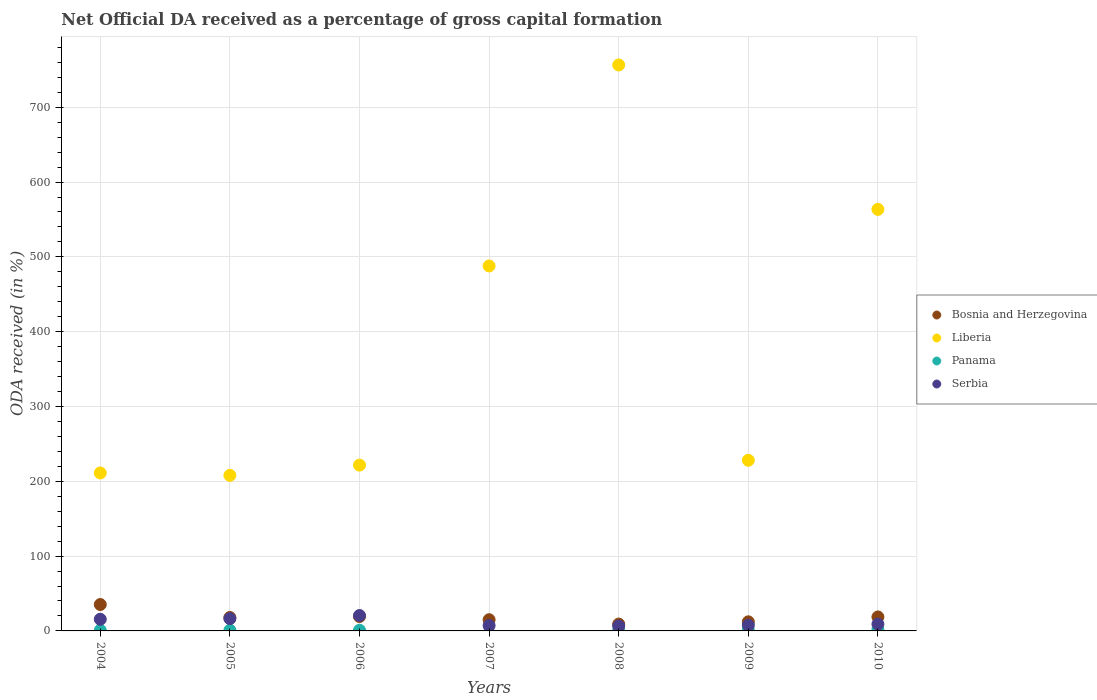What is the net ODA received in Panama in 2004?
Provide a succinct answer. 0.85. Across all years, what is the maximum net ODA received in Serbia?
Make the answer very short. 20.6. Across all years, what is the minimum net ODA received in Liberia?
Offer a very short reply. 207.93. What is the total net ODA received in Bosnia and Herzegovina in the graph?
Your answer should be compact. 127.48. What is the difference between the net ODA received in Serbia in 2005 and that in 2010?
Your answer should be compact. 7.35. What is the difference between the net ODA received in Liberia in 2004 and the net ODA received in Panama in 2010?
Ensure brevity in your answer.  209.27. What is the average net ODA received in Panama per year?
Give a very brief answer. 0.87. In the year 2009, what is the difference between the net ODA received in Serbia and net ODA received in Bosnia and Herzegovina?
Give a very brief answer. -4.62. What is the ratio of the net ODA received in Liberia in 2006 to that in 2007?
Provide a short and direct response. 0.45. What is the difference between the highest and the second highest net ODA received in Serbia?
Offer a very short reply. 4.19. What is the difference between the highest and the lowest net ODA received in Bosnia and Herzegovina?
Provide a succinct answer. 26.12. In how many years, is the net ODA received in Bosnia and Herzegovina greater than the average net ODA received in Bosnia and Herzegovina taken over all years?
Offer a very short reply. 3. Is the sum of the net ODA received in Panama in 2004 and 2008 greater than the maximum net ODA received in Bosnia and Herzegovina across all years?
Provide a succinct answer. No. Is it the case that in every year, the sum of the net ODA received in Bosnia and Herzegovina and net ODA received in Serbia  is greater than the sum of net ODA received in Panama and net ODA received in Liberia?
Ensure brevity in your answer.  No. Is it the case that in every year, the sum of the net ODA received in Serbia and net ODA received in Liberia  is greater than the net ODA received in Bosnia and Herzegovina?
Provide a succinct answer. Yes. Is the net ODA received in Panama strictly greater than the net ODA received in Serbia over the years?
Ensure brevity in your answer.  No. How many dotlines are there?
Give a very brief answer. 4. How many years are there in the graph?
Keep it short and to the point. 7. Does the graph contain grids?
Keep it short and to the point. Yes. Where does the legend appear in the graph?
Give a very brief answer. Center right. How many legend labels are there?
Your response must be concise. 4. How are the legend labels stacked?
Your answer should be very brief. Vertical. What is the title of the graph?
Ensure brevity in your answer.  Net Official DA received as a percentage of gross capital formation. Does "Macao" appear as one of the legend labels in the graph?
Ensure brevity in your answer.  No. What is the label or title of the X-axis?
Your answer should be compact. Years. What is the label or title of the Y-axis?
Provide a succinct answer. ODA received (in %). What is the ODA received (in %) of Bosnia and Herzegovina in 2004?
Keep it short and to the point. 35.29. What is the ODA received (in %) of Liberia in 2004?
Provide a succinct answer. 211.14. What is the ODA received (in %) in Panama in 2004?
Provide a short and direct response. 0.85. What is the ODA received (in %) in Serbia in 2004?
Make the answer very short. 15.6. What is the ODA received (in %) of Bosnia and Herzegovina in 2005?
Your answer should be very brief. 17.96. What is the ODA received (in %) of Liberia in 2005?
Offer a very short reply. 207.93. What is the ODA received (in %) of Panama in 2005?
Offer a terse response. 0.94. What is the ODA received (in %) in Serbia in 2005?
Your response must be concise. 16.41. What is the ODA received (in %) in Bosnia and Herzegovina in 2006?
Give a very brief answer. 19.22. What is the ODA received (in %) in Liberia in 2006?
Your answer should be compact. 221.64. What is the ODA received (in %) of Panama in 2006?
Your response must be concise. 0.93. What is the ODA received (in %) in Serbia in 2006?
Make the answer very short. 20.6. What is the ODA received (in %) in Bosnia and Herzegovina in 2007?
Give a very brief answer. 14.98. What is the ODA received (in %) in Liberia in 2007?
Give a very brief answer. 487.84. What is the ODA received (in %) of Panama in 2007?
Your answer should be very brief. 0. What is the ODA received (in %) in Serbia in 2007?
Offer a terse response. 7.16. What is the ODA received (in %) of Bosnia and Herzegovina in 2008?
Offer a very short reply. 9.17. What is the ODA received (in %) of Liberia in 2008?
Ensure brevity in your answer.  756.47. What is the ODA received (in %) in Panama in 2008?
Your response must be concise. 0.45. What is the ODA received (in %) in Serbia in 2008?
Your response must be concise. 6.51. What is the ODA received (in %) in Bosnia and Herzegovina in 2009?
Ensure brevity in your answer.  12.16. What is the ODA received (in %) in Liberia in 2009?
Provide a short and direct response. 228.08. What is the ODA received (in %) in Panama in 2009?
Offer a very short reply. 1.05. What is the ODA received (in %) in Serbia in 2009?
Your answer should be compact. 7.54. What is the ODA received (in %) of Bosnia and Herzegovina in 2010?
Keep it short and to the point. 18.69. What is the ODA received (in %) in Liberia in 2010?
Ensure brevity in your answer.  563.45. What is the ODA received (in %) in Panama in 2010?
Offer a terse response. 1.87. What is the ODA received (in %) in Serbia in 2010?
Ensure brevity in your answer.  9.05. Across all years, what is the maximum ODA received (in %) in Bosnia and Herzegovina?
Ensure brevity in your answer.  35.29. Across all years, what is the maximum ODA received (in %) of Liberia?
Provide a short and direct response. 756.47. Across all years, what is the maximum ODA received (in %) in Panama?
Make the answer very short. 1.87. Across all years, what is the maximum ODA received (in %) of Serbia?
Give a very brief answer. 20.6. Across all years, what is the minimum ODA received (in %) of Bosnia and Herzegovina?
Provide a short and direct response. 9.17. Across all years, what is the minimum ODA received (in %) of Liberia?
Make the answer very short. 207.93. Across all years, what is the minimum ODA received (in %) in Panama?
Provide a succinct answer. 0. Across all years, what is the minimum ODA received (in %) in Serbia?
Provide a succinct answer. 6.51. What is the total ODA received (in %) of Bosnia and Herzegovina in the graph?
Your response must be concise. 127.48. What is the total ODA received (in %) of Liberia in the graph?
Make the answer very short. 2676.56. What is the total ODA received (in %) of Panama in the graph?
Provide a short and direct response. 6.09. What is the total ODA received (in %) in Serbia in the graph?
Give a very brief answer. 82.88. What is the difference between the ODA received (in %) of Bosnia and Herzegovina in 2004 and that in 2005?
Your answer should be very brief. 17.33. What is the difference between the ODA received (in %) in Liberia in 2004 and that in 2005?
Your answer should be compact. 3.2. What is the difference between the ODA received (in %) in Panama in 2004 and that in 2005?
Keep it short and to the point. -0.09. What is the difference between the ODA received (in %) in Serbia in 2004 and that in 2005?
Your answer should be very brief. -0.81. What is the difference between the ODA received (in %) in Bosnia and Herzegovina in 2004 and that in 2006?
Provide a short and direct response. 16.07. What is the difference between the ODA received (in %) of Liberia in 2004 and that in 2006?
Ensure brevity in your answer.  -10.5. What is the difference between the ODA received (in %) of Panama in 2004 and that in 2006?
Your response must be concise. -0.08. What is the difference between the ODA received (in %) of Serbia in 2004 and that in 2006?
Provide a short and direct response. -5. What is the difference between the ODA received (in %) in Bosnia and Herzegovina in 2004 and that in 2007?
Your answer should be compact. 20.31. What is the difference between the ODA received (in %) of Liberia in 2004 and that in 2007?
Give a very brief answer. -276.7. What is the difference between the ODA received (in %) of Serbia in 2004 and that in 2007?
Make the answer very short. 8.44. What is the difference between the ODA received (in %) in Bosnia and Herzegovina in 2004 and that in 2008?
Your answer should be compact. 26.12. What is the difference between the ODA received (in %) in Liberia in 2004 and that in 2008?
Give a very brief answer. -545.33. What is the difference between the ODA received (in %) of Panama in 2004 and that in 2008?
Give a very brief answer. 0.4. What is the difference between the ODA received (in %) of Serbia in 2004 and that in 2008?
Provide a succinct answer. 9.09. What is the difference between the ODA received (in %) of Bosnia and Herzegovina in 2004 and that in 2009?
Your response must be concise. 23.13. What is the difference between the ODA received (in %) of Liberia in 2004 and that in 2009?
Your response must be concise. -16.95. What is the difference between the ODA received (in %) of Panama in 2004 and that in 2009?
Your answer should be very brief. -0.2. What is the difference between the ODA received (in %) of Serbia in 2004 and that in 2009?
Provide a short and direct response. 8.06. What is the difference between the ODA received (in %) in Bosnia and Herzegovina in 2004 and that in 2010?
Make the answer very short. 16.6. What is the difference between the ODA received (in %) in Liberia in 2004 and that in 2010?
Offer a terse response. -352.31. What is the difference between the ODA received (in %) in Panama in 2004 and that in 2010?
Offer a terse response. -1.01. What is the difference between the ODA received (in %) of Serbia in 2004 and that in 2010?
Offer a very short reply. 6.55. What is the difference between the ODA received (in %) of Bosnia and Herzegovina in 2005 and that in 2006?
Offer a very short reply. -1.26. What is the difference between the ODA received (in %) in Liberia in 2005 and that in 2006?
Ensure brevity in your answer.  -13.7. What is the difference between the ODA received (in %) of Panama in 2005 and that in 2006?
Ensure brevity in your answer.  0.01. What is the difference between the ODA received (in %) of Serbia in 2005 and that in 2006?
Your answer should be compact. -4.19. What is the difference between the ODA received (in %) in Bosnia and Herzegovina in 2005 and that in 2007?
Keep it short and to the point. 2.99. What is the difference between the ODA received (in %) in Liberia in 2005 and that in 2007?
Your response must be concise. -279.91. What is the difference between the ODA received (in %) in Serbia in 2005 and that in 2007?
Your answer should be compact. 9.24. What is the difference between the ODA received (in %) of Bosnia and Herzegovina in 2005 and that in 2008?
Your response must be concise. 8.79. What is the difference between the ODA received (in %) of Liberia in 2005 and that in 2008?
Make the answer very short. -548.54. What is the difference between the ODA received (in %) of Panama in 2005 and that in 2008?
Provide a succinct answer. 0.49. What is the difference between the ODA received (in %) of Serbia in 2005 and that in 2008?
Offer a very short reply. 9.89. What is the difference between the ODA received (in %) of Bosnia and Herzegovina in 2005 and that in 2009?
Your answer should be compact. 5.8. What is the difference between the ODA received (in %) in Liberia in 2005 and that in 2009?
Your answer should be very brief. -20.15. What is the difference between the ODA received (in %) of Panama in 2005 and that in 2009?
Offer a terse response. -0.11. What is the difference between the ODA received (in %) in Serbia in 2005 and that in 2009?
Your response must be concise. 8.87. What is the difference between the ODA received (in %) in Bosnia and Herzegovina in 2005 and that in 2010?
Provide a succinct answer. -0.73. What is the difference between the ODA received (in %) in Liberia in 2005 and that in 2010?
Your answer should be compact. -355.51. What is the difference between the ODA received (in %) in Panama in 2005 and that in 2010?
Give a very brief answer. -0.93. What is the difference between the ODA received (in %) in Serbia in 2005 and that in 2010?
Ensure brevity in your answer.  7.35. What is the difference between the ODA received (in %) in Bosnia and Herzegovina in 2006 and that in 2007?
Your answer should be compact. 4.24. What is the difference between the ODA received (in %) of Liberia in 2006 and that in 2007?
Give a very brief answer. -266.2. What is the difference between the ODA received (in %) in Serbia in 2006 and that in 2007?
Offer a terse response. 13.43. What is the difference between the ODA received (in %) in Bosnia and Herzegovina in 2006 and that in 2008?
Provide a succinct answer. 10.05. What is the difference between the ODA received (in %) of Liberia in 2006 and that in 2008?
Provide a succinct answer. -534.83. What is the difference between the ODA received (in %) in Panama in 2006 and that in 2008?
Your answer should be compact. 0.48. What is the difference between the ODA received (in %) of Serbia in 2006 and that in 2008?
Provide a succinct answer. 14.08. What is the difference between the ODA received (in %) of Bosnia and Herzegovina in 2006 and that in 2009?
Offer a terse response. 7.06. What is the difference between the ODA received (in %) in Liberia in 2006 and that in 2009?
Make the answer very short. -6.45. What is the difference between the ODA received (in %) in Panama in 2006 and that in 2009?
Your response must be concise. -0.12. What is the difference between the ODA received (in %) of Serbia in 2006 and that in 2009?
Provide a short and direct response. 13.06. What is the difference between the ODA received (in %) of Bosnia and Herzegovina in 2006 and that in 2010?
Offer a terse response. 0.53. What is the difference between the ODA received (in %) of Liberia in 2006 and that in 2010?
Provide a succinct answer. -341.81. What is the difference between the ODA received (in %) of Panama in 2006 and that in 2010?
Make the answer very short. -0.94. What is the difference between the ODA received (in %) in Serbia in 2006 and that in 2010?
Provide a short and direct response. 11.54. What is the difference between the ODA received (in %) of Bosnia and Herzegovina in 2007 and that in 2008?
Give a very brief answer. 5.81. What is the difference between the ODA received (in %) of Liberia in 2007 and that in 2008?
Your answer should be compact. -268.63. What is the difference between the ODA received (in %) of Serbia in 2007 and that in 2008?
Your answer should be very brief. 0.65. What is the difference between the ODA received (in %) in Bosnia and Herzegovina in 2007 and that in 2009?
Your response must be concise. 2.82. What is the difference between the ODA received (in %) in Liberia in 2007 and that in 2009?
Your answer should be compact. 259.76. What is the difference between the ODA received (in %) of Serbia in 2007 and that in 2009?
Provide a succinct answer. -0.37. What is the difference between the ODA received (in %) of Bosnia and Herzegovina in 2007 and that in 2010?
Give a very brief answer. -3.71. What is the difference between the ODA received (in %) of Liberia in 2007 and that in 2010?
Keep it short and to the point. -75.61. What is the difference between the ODA received (in %) of Serbia in 2007 and that in 2010?
Provide a short and direct response. -1.89. What is the difference between the ODA received (in %) in Bosnia and Herzegovina in 2008 and that in 2009?
Provide a succinct answer. -2.99. What is the difference between the ODA received (in %) in Liberia in 2008 and that in 2009?
Ensure brevity in your answer.  528.39. What is the difference between the ODA received (in %) of Panama in 2008 and that in 2009?
Your answer should be compact. -0.6. What is the difference between the ODA received (in %) of Serbia in 2008 and that in 2009?
Offer a terse response. -1.02. What is the difference between the ODA received (in %) in Bosnia and Herzegovina in 2008 and that in 2010?
Provide a short and direct response. -9.52. What is the difference between the ODA received (in %) of Liberia in 2008 and that in 2010?
Ensure brevity in your answer.  193.02. What is the difference between the ODA received (in %) of Panama in 2008 and that in 2010?
Offer a very short reply. -1.42. What is the difference between the ODA received (in %) in Serbia in 2008 and that in 2010?
Your answer should be very brief. -2.54. What is the difference between the ODA received (in %) in Bosnia and Herzegovina in 2009 and that in 2010?
Provide a short and direct response. -6.53. What is the difference between the ODA received (in %) in Liberia in 2009 and that in 2010?
Offer a terse response. -335.37. What is the difference between the ODA received (in %) of Panama in 2009 and that in 2010?
Your response must be concise. -0.81. What is the difference between the ODA received (in %) of Serbia in 2009 and that in 2010?
Your answer should be very brief. -1.52. What is the difference between the ODA received (in %) of Bosnia and Herzegovina in 2004 and the ODA received (in %) of Liberia in 2005?
Your response must be concise. -172.64. What is the difference between the ODA received (in %) of Bosnia and Herzegovina in 2004 and the ODA received (in %) of Panama in 2005?
Keep it short and to the point. 34.35. What is the difference between the ODA received (in %) of Bosnia and Herzegovina in 2004 and the ODA received (in %) of Serbia in 2005?
Ensure brevity in your answer.  18.88. What is the difference between the ODA received (in %) in Liberia in 2004 and the ODA received (in %) in Panama in 2005?
Offer a terse response. 210.2. What is the difference between the ODA received (in %) of Liberia in 2004 and the ODA received (in %) of Serbia in 2005?
Provide a short and direct response. 194.73. What is the difference between the ODA received (in %) of Panama in 2004 and the ODA received (in %) of Serbia in 2005?
Give a very brief answer. -15.56. What is the difference between the ODA received (in %) of Bosnia and Herzegovina in 2004 and the ODA received (in %) of Liberia in 2006?
Give a very brief answer. -186.35. What is the difference between the ODA received (in %) of Bosnia and Herzegovina in 2004 and the ODA received (in %) of Panama in 2006?
Give a very brief answer. 34.36. What is the difference between the ODA received (in %) in Bosnia and Herzegovina in 2004 and the ODA received (in %) in Serbia in 2006?
Your answer should be very brief. 14.69. What is the difference between the ODA received (in %) of Liberia in 2004 and the ODA received (in %) of Panama in 2006?
Your response must be concise. 210.21. What is the difference between the ODA received (in %) in Liberia in 2004 and the ODA received (in %) in Serbia in 2006?
Your response must be concise. 190.54. What is the difference between the ODA received (in %) in Panama in 2004 and the ODA received (in %) in Serbia in 2006?
Ensure brevity in your answer.  -19.75. What is the difference between the ODA received (in %) of Bosnia and Herzegovina in 2004 and the ODA received (in %) of Liberia in 2007?
Make the answer very short. -452.55. What is the difference between the ODA received (in %) of Bosnia and Herzegovina in 2004 and the ODA received (in %) of Serbia in 2007?
Make the answer very short. 28.13. What is the difference between the ODA received (in %) in Liberia in 2004 and the ODA received (in %) in Serbia in 2007?
Provide a succinct answer. 203.97. What is the difference between the ODA received (in %) of Panama in 2004 and the ODA received (in %) of Serbia in 2007?
Provide a succinct answer. -6.31. What is the difference between the ODA received (in %) of Bosnia and Herzegovina in 2004 and the ODA received (in %) of Liberia in 2008?
Your answer should be compact. -721.18. What is the difference between the ODA received (in %) in Bosnia and Herzegovina in 2004 and the ODA received (in %) in Panama in 2008?
Offer a very short reply. 34.84. What is the difference between the ODA received (in %) of Bosnia and Herzegovina in 2004 and the ODA received (in %) of Serbia in 2008?
Give a very brief answer. 28.78. What is the difference between the ODA received (in %) of Liberia in 2004 and the ODA received (in %) of Panama in 2008?
Offer a terse response. 210.69. What is the difference between the ODA received (in %) of Liberia in 2004 and the ODA received (in %) of Serbia in 2008?
Keep it short and to the point. 204.62. What is the difference between the ODA received (in %) of Panama in 2004 and the ODA received (in %) of Serbia in 2008?
Keep it short and to the point. -5.66. What is the difference between the ODA received (in %) in Bosnia and Herzegovina in 2004 and the ODA received (in %) in Liberia in 2009?
Provide a succinct answer. -192.79. What is the difference between the ODA received (in %) in Bosnia and Herzegovina in 2004 and the ODA received (in %) in Panama in 2009?
Your answer should be very brief. 34.24. What is the difference between the ODA received (in %) in Bosnia and Herzegovina in 2004 and the ODA received (in %) in Serbia in 2009?
Your answer should be compact. 27.75. What is the difference between the ODA received (in %) in Liberia in 2004 and the ODA received (in %) in Panama in 2009?
Keep it short and to the point. 210.09. What is the difference between the ODA received (in %) of Liberia in 2004 and the ODA received (in %) of Serbia in 2009?
Offer a terse response. 203.6. What is the difference between the ODA received (in %) of Panama in 2004 and the ODA received (in %) of Serbia in 2009?
Your answer should be compact. -6.69. What is the difference between the ODA received (in %) of Bosnia and Herzegovina in 2004 and the ODA received (in %) of Liberia in 2010?
Provide a short and direct response. -528.16. What is the difference between the ODA received (in %) in Bosnia and Herzegovina in 2004 and the ODA received (in %) in Panama in 2010?
Your response must be concise. 33.43. What is the difference between the ODA received (in %) of Bosnia and Herzegovina in 2004 and the ODA received (in %) of Serbia in 2010?
Provide a short and direct response. 26.24. What is the difference between the ODA received (in %) in Liberia in 2004 and the ODA received (in %) in Panama in 2010?
Your answer should be very brief. 209.27. What is the difference between the ODA received (in %) of Liberia in 2004 and the ODA received (in %) of Serbia in 2010?
Your answer should be very brief. 202.08. What is the difference between the ODA received (in %) of Panama in 2004 and the ODA received (in %) of Serbia in 2010?
Your answer should be compact. -8.2. What is the difference between the ODA received (in %) in Bosnia and Herzegovina in 2005 and the ODA received (in %) in Liberia in 2006?
Ensure brevity in your answer.  -203.68. What is the difference between the ODA received (in %) of Bosnia and Herzegovina in 2005 and the ODA received (in %) of Panama in 2006?
Keep it short and to the point. 17.03. What is the difference between the ODA received (in %) in Bosnia and Herzegovina in 2005 and the ODA received (in %) in Serbia in 2006?
Your answer should be very brief. -2.63. What is the difference between the ODA received (in %) of Liberia in 2005 and the ODA received (in %) of Panama in 2006?
Make the answer very short. 207. What is the difference between the ODA received (in %) in Liberia in 2005 and the ODA received (in %) in Serbia in 2006?
Offer a very short reply. 187.34. What is the difference between the ODA received (in %) in Panama in 2005 and the ODA received (in %) in Serbia in 2006?
Provide a short and direct response. -19.66. What is the difference between the ODA received (in %) of Bosnia and Herzegovina in 2005 and the ODA received (in %) of Liberia in 2007?
Make the answer very short. -469.88. What is the difference between the ODA received (in %) in Bosnia and Herzegovina in 2005 and the ODA received (in %) in Serbia in 2007?
Your response must be concise. 10.8. What is the difference between the ODA received (in %) of Liberia in 2005 and the ODA received (in %) of Serbia in 2007?
Offer a very short reply. 200.77. What is the difference between the ODA received (in %) in Panama in 2005 and the ODA received (in %) in Serbia in 2007?
Ensure brevity in your answer.  -6.22. What is the difference between the ODA received (in %) of Bosnia and Herzegovina in 2005 and the ODA received (in %) of Liberia in 2008?
Provide a succinct answer. -738.51. What is the difference between the ODA received (in %) in Bosnia and Herzegovina in 2005 and the ODA received (in %) in Panama in 2008?
Make the answer very short. 17.51. What is the difference between the ODA received (in %) of Bosnia and Herzegovina in 2005 and the ODA received (in %) of Serbia in 2008?
Offer a very short reply. 11.45. What is the difference between the ODA received (in %) of Liberia in 2005 and the ODA received (in %) of Panama in 2008?
Your response must be concise. 207.49. What is the difference between the ODA received (in %) of Liberia in 2005 and the ODA received (in %) of Serbia in 2008?
Make the answer very short. 201.42. What is the difference between the ODA received (in %) in Panama in 2005 and the ODA received (in %) in Serbia in 2008?
Offer a very short reply. -5.57. What is the difference between the ODA received (in %) of Bosnia and Herzegovina in 2005 and the ODA received (in %) of Liberia in 2009?
Offer a terse response. -210.12. What is the difference between the ODA received (in %) in Bosnia and Herzegovina in 2005 and the ODA received (in %) in Panama in 2009?
Make the answer very short. 16.91. What is the difference between the ODA received (in %) of Bosnia and Herzegovina in 2005 and the ODA received (in %) of Serbia in 2009?
Your answer should be compact. 10.43. What is the difference between the ODA received (in %) of Liberia in 2005 and the ODA received (in %) of Panama in 2009?
Provide a succinct answer. 206.88. What is the difference between the ODA received (in %) in Liberia in 2005 and the ODA received (in %) in Serbia in 2009?
Provide a succinct answer. 200.4. What is the difference between the ODA received (in %) in Panama in 2005 and the ODA received (in %) in Serbia in 2009?
Provide a succinct answer. -6.6. What is the difference between the ODA received (in %) in Bosnia and Herzegovina in 2005 and the ODA received (in %) in Liberia in 2010?
Provide a succinct answer. -545.49. What is the difference between the ODA received (in %) of Bosnia and Herzegovina in 2005 and the ODA received (in %) of Panama in 2010?
Give a very brief answer. 16.1. What is the difference between the ODA received (in %) of Bosnia and Herzegovina in 2005 and the ODA received (in %) of Serbia in 2010?
Provide a succinct answer. 8.91. What is the difference between the ODA received (in %) in Liberia in 2005 and the ODA received (in %) in Panama in 2010?
Make the answer very short. 206.07. What is the difference between the ODA received (in %) in Liberia in 2005 and the ODA received (in %) in Serbia in 2010?
Give a very brief answer. 198.88. What is the difference between the ODA received (in %) in Panama in 2005 and the ODA received (in %) in Serbia in 2010?
Offer a very short reply. -8.11. What is the difference between the ODA received (in %) in Bosnia and Herzegovina in 2006 and the ODA received (in %) in Liberia in 2007?
Your response must be concise. -468.62. What is the difference between the ODA received (in %) of Bosnia and Herzegovina in 2006 and the ODA received (in %) of Serbia in 2007?
Ensure brevity in your answer.  12.06. What is the difference between the ODA received (in %) in Liberia in 2006 and the ODA received (in %) in Serbia in 2007?
Provide a succinct answer. 214.47. What is the difference between the ODA received (in %) in Panama in 2006 and the ODA received (in %) in Serbia in 2007?
Offer a very short reply. -6.23. What is the difference between the ODA received (in %) in Bosnia and Herzegovina in 2006 and the ODA received (in %) in Liberia in 2008?
Give a very brief answer. -737.25. What is the difference between the ODA received (in %) of Bosnia and Herzegovina in 2006 and the ODA received (in %) of Panama in 2008?
Provide a succinct answer. 18.77. What is the difference between the ODA received (in %) in Bosnia and Herzegovina in 2006 and the ODA received (in %) in Serbia in 2008?
Your answer should be compact. 12.71. What is the difference between the ODA received (in %) in Liberia in 2006 and the ODA received (in %) in Panama in 2008?
Offer a terse response. 221.19. What is the difference between the ODA received (in %) of Liberia in 2006 and the ODA received (in %) of Serbia in 2008?
Your answer should be very brief. 215.12. What is the difference between the ODA received (in %) of Panama in 2006 and the ODA received (in %) of Serbia in 2008?
Your answer should be compact. -5.58. What is the difference between the ODA received (in %) in Bosnia and Herzegovina in 2006 and the ODA received (in %) in Liberia in 2009?
Ensure brevity in your answer.  -208.86. What is the difference between the ODA received (in %) in Bosnia and Herzegovina in 2006 and the ODA received (in %) in Panama in 2009?
Offer a very short reply. 18.17. What is the difference between the ODA received (in %) of Bosnia and Herzegovina in 2006 and the ODA received (in %) of Serbia in 2009?
Your response must be concise. 11.68. What is the difference between the ODA received (in %) in Liberia in 2006 and the ODA received (in %) in Panama in 2009?
Your response must be concise. 220.59. What is the difference between the ODA received (in %) in Liberia in 2006 and the ODA received (in %) in Serbia in 2009?
Provide a succinct answer. 214.1. What is the difference between the ODA received (in %) in Panama in 2006 and the ODA received (in %) in Serbia in 2009?
Make the answer very short. -6.61. What is the difference between the ODA received (in %) in Bosnia and Herzegovina in 2006 and the ODA received (in %) in Liberia in 2010?
Make the answer very short. -544.23. What is the difference between the ODA received (in %) in Bosnia and Herzegovina in 2006 and the ODA received (in %) in Panama in 2010?
Make the answer very short. 17.35. What is the difference between the ODA received (in %) of Bosnia and Herzegovina in 2006 and the ODA received (in %) of Serbia in 2010?
Offer a terse response. 10.17. What is the difference between the ODA received (in %) of Liberia in 2006 and the ODA received (in %) of Panama in 2010?
Provide a short and direct response. 219.77. What is the difference between the ODA received (in %) of Liberia in 2006 and the ODA received (in %) of Serbia in 2010?
Offer a terse response. 212.58. What is the difference between the ODA received (in %) of Panama in 2006 and the ODA received (in %) of Serbia in 2010?
Your answer should be compact. -8.12. What is the difference between the ODA received (in %) of Bosnia and Herzegovina in 2007 and the ODA received (in %) of Liberia in 2008?
Your answer should be compact. -741.49. What is the difference between the ODA received (in %) of Bosnia and Herzegovina in 2007 and the ODA received (in %) of Panama in 2008?
Your answer should be very brief. 14.53. What is the difference between the ODA received (in %) in Bosnia and Herzegovina in 2007 and the ODA received (in %) in Serbia in 2008?
Your answer should be compact. 8.46. What is the difference between the ODA received (in %) of Liberia in 2007 and the ODA received (in %) of Panama in 2008?
Your response must be concise. 487.39. What is the difference between the ODA received (in %) of Liberia in 2007 and the ODA received (in %) of Serbia in 2008?
Your answer should be very brief. 481.33. What is the difference between the ODA received (in %) of Bosnia and Herzegovina in 2007 and the ODA received (in %) of Liberia in 2009?
Your answer should be very brief. -213.11. What is the difference between the ODA received (in %) in Bosnia and Herzegovina in 2007 and the ODA received (in %) in Panama in 2009?
Offer a very short reply. 13.92. What is the difference between the ODA received (in %) of Bosnia and Herzegovina in 2007 and the ODA received (in %) of Serbia in 2009?
Provide a succinct answer. 7.44. What is the difference between the ODA received (in %) in Liberia in 2007 and the ODA received (in %) in Panama in 2009?
Your answer should be compact. 486.79. What is the difference between the ODA received (in %) in Liberia in 2007 and the ODA received (in %) in Serbia in 2009?
Provide a succinct answer. 480.3. What is the difference between the ODA received (in %) in Bosnia and Herzegovina in 2007 and the ODA received (in %) in Liberia in 2010?
Provide a succinct answer. -548.47. What is the difference between the ODA received (in %) in Bosnia and Herzegovina in 2007 and the ODA received (in %) in Panama in 2010?
Make the answer very short. 13.11. What is the difference between the ODA received (in %) of Bosnia and Herzegovina in 2007 and the ODA received (in %) of Serbia in 2010?
Your response must be concise. 5.92. What is the difference between the ODA received (in %) of Liberia in 2007 and the ODA received (in %) of Panama in 2010?
Your response must be concise. 485.97. What is the difference between the ODA received (in %) in Liberia in 2007 and the ODA received (in %) in Serbia in 2010?
Provide a short and direct response. 478.79. What is the difference between the ODA received (in %) in Bosnia and Herzegovina in 2008 and the ODA received (in %) in Liberia in 2009?
Make the answer very short. -218.91. What is the difference between the ODA received (in %) in Bosnia and Herzegovina in 2008 and the ODA received (in %) in Panama in 2009?
Offer a terse response. 8.12. What is the difference between the ODA received (in %) in Bosnia and Herzegovina in 2008 and the ODA received (in %) in Serbia in 2009?
Offer a terse response. 1.63. What is the difference between the ODA received (in %) of Liberia in 2008 and the ODA received (in %) of Panama in 2009?
Provide a succinct answer. 755.42. What is the difference between the ODA received (in %) of Liberia in 2008 and the ODA received (in %) of Serbia in 2009?
Make the answer very short. 748.93. What is the difference between the ODA received (in %) in Panama in 2008 and the ODA received (in %) in Serbia in 2009?
Give a very brief answer. -7.09. What is the difference between the ODA received (in %) in Bosnia and Herzegovina in 2008 and the ODA received (in %) in Liberia in 2010?
Offer a very short reply. -554.28. What is the difference between the ODA received (in %) of Bosnia and Herzegovina in 2008 and the ODA received (in %) of Panama in 2010?
Your answer should be compact. 7.31. What is the difference between the ODA received (in %) in Bosnia and Herzegovina in 2008 and the ODA received (in %) in Serbia in 2010?
Offer a terse response. 0.12. What is the difference between the ODA received (in %) in Liberia in 2008 and the ODA received (in %) in Panama in 2010?
Ensure brevity in your answer.  754.61. What is the difference between the ODA received (in %) of Liberia in 2008 and the ODA received (in %) of Serbia in 2010?
Your response must be concise. 747.42. What is the difference between the ODA received (in %) of Panama in 2008 and the ODA received (in %) of Serbia in 2010?
Give a very brief answer. -8.61. What is the difference between the ODA received (in %) in Bosnia and Herzegovina in 2009 and the ODA received (in %) in Liberia in 2010?
Provide a succinct answer. -551.29. What is the difference between the ODA received (in %) in Bosnia and Herzegovina in 2009 and the ODA received (in %) in Panama in 2010?
Make the answer very short. 10.3. What is the difference between the ODA received (in %) in Bosnia and Herzegovina in 2009 and the ODA received (in %) in Serbia in 2010?
Ensure brevity in your answer.  3.11. What is the difference between the ODA received (in %) of Liberia in 2009 and the ODA received (in %) of Panama in 2010?
Offer a very short reply. 226.22. What is the difference between the ODA received (in %) in Liberia in 2009 and the ODA received (in %) in Serbia in 2010?
Provide a short and direct response. 219.03. What is the difference between the ODA received (in %) of Panama in 2009 and the ODA received (in %) of Serbia in 2010?
Your response must be concise. -8. What is the average ODA received (in %) of Bosnia and Herzegovina per year?
Your answer should be compact. 18.21. What is the average ODA received (in %) in Liberia per year?
Provide a succinct answer. 382.37. What is the average ODA received (in %) in Panama per year?
Keep it short and to the point. 0.87. What is the average ODA received (in %) in Serbia per year?
Ensure brevity in your answer.  11.84. In the year 2004, what is the difference between the ODA received (in %) in Bosnia and Herzegovina and ODA received (in %) in Liberia?
Offer a very short reply. -175.85. In the year 2004, what is the difference between the ODA received (in %) in Bosnia and Herzegovina and ODA received (in %) in Panama?
Give a very brief answer. 34.44. In the year 2004, what is the difference between the ODA received (in %) in Bosnia and Herzegovina and ODA received (in %) in Serbia?
Offer a very short reply. 19.69. In the year 2004, what is the difference between the ODA received (in %) in Liberia and ODA received (in %) in Panama?
Your response must be concise. 210.29. In the year 2004, what is the difference between the ODA received (in %) of Liberia and ODA received (in %) of Serbia?
Offer a terse response. 195.54. In the year 2004, what is the difference between the ODA received (in %) of Panama and ODA received (in %) of Serbia?
Give a very brief answer. -14.75. In the year 2005, what is the difference between the ODA received (in %) of Bosnia and Herzegovina and ODA received (in %) of Liberia?
Ensure brevity in your answer.  -189.97. In the year 2005, what is the difference between the ODA received (in %) of Bosnia and Herzegovina and ODA received (in %) of Panama?
Offer a very short reply. 17.02. In the year 2005, what is the difference between the ODA received (in %) of Bosnia and Herzegovina and ODA received (in %) of Serbia?
Ensure brevity in your answer.  1.55. In the year 2005, what is the difference between the ODA received (in %) in Liberia and ODA received (in %) in Panama?
Your answer should be compact. 206.99. In the year 2005, what is the difference between the ODA received (in %) in Liberia and ODA received (in %) in Serbia?
Provide a short and direct response. 191.53. In the year 2005, what is the difference between the ODA received (in %) in Panama and ODA received (in %) in Serbia?
Offer a terse response. -15.47. In the year 2006, what is the difference between the ODA received (in %) of Bosnia and Herzegovina and ODA received (in %) of Liberia?
Ensure brevity in your answer.  -202.42. In the year 2006, what is the difference between the ODA received (in %) of Bosnia and Herzegovina and ODA received (in %) of Panama?
Your response must be concise. 18.29. In the year 2006, what is the difference between the ODA received (in %) in Bosnia and Herzegovina and ODA received (in %) in Serbia?
Give a very brief answer. -1.38. In the year 2006, what is the difference between the ODA received (in %) of Liberia and ODA received (in %) of Panama?
Offer a terse response. 220.71. In the year 2006, what is the difference between the ODA received (in %) of Liberia and ODA received (in %) of Serbia?
Provide a succinct answer. 201.04. In the year 2006, what is the difference between the ODA received (in %) in Panama and ODA received (in %) in Serbia?
Give a very brief answer. -19.67. In the year 2007, what is the difference between the ODA received (in %) of Bosnia and Herzegovina and ODA received (in %) of Liberia?
Offer a terse response. -472.86. In the year 2007, what is the difference between the ODA received (in %) of Bosnia and Herzegovina and ODA received (in %) of Serbia?
Offer a terse response. 7.81. In the year 2007, what is the difference between the ODA received (in %) of Liberia and ODA received (in %) of Serbia?
Your response must be concise. 480.68. In the year 2008, what is the difference between the ODA received (in %) of Bosnia and Herzegovina and ODA received (in %) of Liberia?
Your answer should be very brief. -747.3. In the year 2008, what is the difference between the ODA received (in %) in Bosnia and Herzegovina and ODA received (in %) in Panama?
Your answer should be very brief. 8.72. In the year 2008, what is the difference between the ODA received (in %) of Bosnia and Herzegovina and ODA received (in %) of Serbia?
Ensure brevity in your answer.  2.66. In the year 2008, what is the difference between the ODA received (in %) in Liberia and ODA received (in %) in Panama?
Your response must be concise. 756.02. In the year 2008, what is the difference between the ODA received (in %) in Liberia and ODA received (in %) in Serbia?
Provide a succinct answer. 749.96. In the year 2008, what is the difference between the ODA received (in %) in Panama and ODA received (in %) in Serbia?
Your answer should be compact. -6.07. In the year 2009, what is the difference between the ODA received (in %) of Bosnia and Herzegovina and ODA received (in %) of Liberia?
Provide a succinct answer. -215.92. In the year 2009, what is the difference between the ODA received (in %) in Bosnia and Herzegovina and ODA received (in %) in Panama?
Offer a terse response. 11.11. In the year 2009, what is the difference between the ODA received (in %) of Bosnia and Herzegovina and ODA received (in %) of Serbia?
Keep it short and to the point. 4.62. In the year 2009, what is the difference between the ODA received (in %) of Liberia and ODA received (in %) of Panama?
Keep it short and to the point. 227.03. In the year 2009, what is the difference between the ODA received (in %) in Liberia and ODA received (in %) in Serbia?
Offer a very short reply. 220.55. In the year 2009, what is the difference between the ODA received (in %) in Panama and ODA received (in %) in Serbia?
Offer a terse response. -6.48. In the year 2010, what is the difference between the ODA received (in %) of Bosnia and Herzegovina and ODA received (in %) of Liberia?
Offer a very short reply. -544.76. In the year 2010, what is the difference between the ODA received (in %) in Bosnia and Herzegovina and ODA received (in %) in Panama?
Your answer should be compact. 16.82. In the year 2010, what is the difference between the ODA received (in %) of Bosnia and Herzegovina and ODA received (in %) of Serbia?
Provide a succinct answer. 9.64. In the year 2010, what is the difference between the ODA received (in %) in Liberia and ODA received (in %) in Panama?
Provide a short and direct response. 561.58. In the year 2010, what is the difference between the ODA received (in %) in Liberia and ODA received (in %) in Serbia?
Provide a succinct answer. 554.4. In the year 2010, what is the difference between the ODA received (in %) of Panama and ODA received (in %) of Serbia?
Keep it short and to the point. -7.19. What is the ratio of the ODA received (in %) of Bosnia and Herzegovina in 2004 to that in 2005?
Provide a short and direct response. 1.96. What is the ratio of the ODA received (in %) of Liberia in 2004 to that in 2005?
Give a very brief answer. 1.02. What is the ratio of the ODA received (in %) of Panama in 2004 to that in 2005?
Keep it short and to the point. 0.91. What is the ratio of the ODA received (in %) in Serbia in 2004 to that in 2005?
Make the answer very short. 0.95. What is the ratio of the ODA received (in %) in Bosnia and Herzegovina in 2004 to that in 2006?
Your response must be concise. 1.84. What is the ratio of the ODA received (in %) in Liberia in 2004 to that in 2006?
Your answer should be very brief. 0.95. What is the ratio of the ODA received (in %) of Panama in 2004 to that in 2006?
Keep it short and to the point. 0.92. What is the ratio of the ODA received (in %) of Serbia in 2004 to that in 2006?
Provide a succinct answer. 0.76. What is the ratio of the ODA received (in %) in Bosnia and Herzegovina in 2004 to that in 2007?
Your answer should be compact. 2.36. What is the ratio of the ODA received (in %) in Liberia in 2004 to that in 2007?
Make the answer very short. 0.43. What is the ratio of the ODA received (in %) in Serbia in 2004 to that in 2007?
Offer a very short reply. 2.18. What is the ratio of the ODA received (in %) in Bosnia and Herzegovina in 2004 to that in 2008?
Offer a very short reply. 3.85. What is the ratio of the ODA received (in %) in Liberia in 2004 to that in 2008?
Your answer should be very brief. 0.28. What is the ratio of the ODA received (in %) of Panama in 2004 to that in 2008?
Your response must be concise. 1.9. What is the ratio of the ODA received (in %) in Serbia in 2004 to that in 2008?
Your answer should be compact. 2.39. What is the ratio of the ODA received (in %) of Bosnia and Herzegovina in 2004 to that in 2009?
Your answer should be compact. 2.9. What is the ratio of the ODA received (in %) of Liberia in 2004 to that in 2009?
Ensure brevity in your answer.  0.93. What is the ratio of the ODA received (in %) in Panama in 2004 to that in 2009?
Ensure brevity in your answer.  0.81. What is the ratio of the ODA received (in %) in Serbia in 2004 to that in 2009?
Offer a very short reply. 2.07. What is the ratio of the ODA received (in %) in Bosnia and Herzegovina in 2004 to that in 2010?
Your answer should be compact. 1.89. What is the ratio of the ODA received (in %) of Liberia in 2004 to that in 2010?
Offer a terse response. 0.37. What is the ratio of the ODA received (in %) of Panama in 2004 to that in 2010?
Provide a short and direct response. 0.46. What is the ratio of the ODA received (in %) in Serbia in 2004 to that in 2010?
Provide a succinct answer. 1.72. What is the ratio of the ODA received (in %) in Bosnia and Herzegovina in 2005 to that in 2006?
Your response must be concise. 0.93. What is the ratio of the ODA received (in %) in Liberia in 2005 to that in 2006?
Your answer should be compact. 0.94. What is the ratio of the ODA received (in %) in Serbia in 2005 to that in 2006?
Keep it short and to the point. 0.8. What is the ratio of the ODA received (in %) in Bosnia and Herzegovina in 2005 to that in 2007?
Your response must be concise. 1.2. What is the ratio of the ODA received (in %) in Liberia in 2005 to that in 2007?
Ensure brevity in your answer.  0.43. What is the ratio of the ODA received (in %) in Serbia in 2005 to that in 2007?
Your response must be concise. 2.29. What is the ratio of the ODA received (in %) in Bosnia and Herzegovina in 2005 to that in 2008?
Give a very brief answer. 1.96. What is the ratio of the ODA received (in %) of Liberia in 2005 to that in 2008?
Your answer should be compact. 0.27. What is the ratio of the ODA received (in %) of Panama in 2005 to that in 2008?
Ensure brevity in your answer.  2.09. What is the ratio of the ODA received (in %) in Serbia in 2005 to that in 2008?
Your answer should be very brief. 2.52. What is the ratio of the ODA received (in %) in Bosnia and Herzegovina in 2005 to that in 2009?
Your answer should be very brief. 1.48. What is the ratio of the ODA received (in %) of Liberia in 2005 to that in 2009?
Provide a short and direct response. 0.91. What is the ratio of the ODA received (in %) in Panama in 2005 to that in 2009?
Provide a short and direct response. 0.89. What is the ratio of the ODA received (in %) in Serbia in 2005 to that in 2009?
Keep it short and to the point. 2.18. What is the ratio of the ODA received (in %) in Bosnia and Herzegovina in 2005 to that in 2010?
Offer a terse response. 0.96. What is the ratio of the ODA received (in %) in Liberia in 2005 to that in 2010?
Your response must be concise. 0.37. What is the ratio of the ODA received (in %) in Panama in 2005 to that in 2010?
Give a very brief answer. 0.5. What is the ratio of the ODA received (in %) of Serbia in 2005 to that in 2010?
Your answer should be compact. 1.81. What is the ratio of the ODA received (in %) of Bosnia and Herzegovina in 2006 to that in 2007?
Offer a very short reply. 1.28. What is the ratio of the ODA received (in %) in Liberia in 2006 to that in 2007?
Offer a terse response. 0.45. What is the ratio of the ODA received (in %) in Serbia in 2006 to that in 2007?
Your response must be concise. 2.87. What is the ratio of the ODA received (in %) in Bosnia and Herzegovina in 2006 to that in 2008?
Give a very brief answer. 2.1. What is the ratio of the ODA received (in %) of Liberia in 2006 to that in 2008?
Your answer should be very brief. 0.29. What is the ratio of the ODA received (in %) of Panama in 2006 to that in 2008?
Provide a short and direct response. 2.07. What is the ratio of the ODA received (in %) of Serbia in 2006 to that in 2008?
Your answer should be compact. 3.16. What is the ratio of the ODA received (in %) in Bosnia and Herzegovina in 2006 to that in 2009?
Keep it short and to the point. 1.58. What is the ratio of the ODA received (in %) of Liberia in 2006 to that in 2009?
Your answer should be very brief. 0.97. What is the ratio of the ODA received (in %) of Panama in 2006 to that in 2009?
Provide a short and direct response. 0.88. What is the ratio of the ODA received (in %) of Serbia in 2006 to that in 2009?
Make the answer very short. 2.73. What is the ratio of the ODA received (in %) of Bosnia and Herzegovina in 2006 to that in 2010?
Your answer should be very brief. 1.03. What is the ratio of the ODA received (in %) of Liberia in 2006 to that in 2010?
Your answer should be compact. 0.39. What is the ratio of the ODA received (in %) of Panama in 2006 to that in 2010?
Keep it short and to the point. 0.5. What is the ratio of the ODA received (in %) in Serbia in 2006 to that in 2010?
Your answer should be compact. 2.27. What is the ratio of the ODA received (in %) of Bosnia and Herzegovina in 2007 to that in 2008?
Your answer should be very brief. 1.63. What is the ratio of the ODA received (in %) of Liberia in 2007 to that in 2008?
Your answer should be very brief. 0.64. What is the ratio of the ODA received (in %) of Serbia in 2007 to that in 2008?
Offer a very short reply. 1.1. What is the ratio of the ODA received (in %) of Bosnia and Herzegovina in 2007 to that in 2009?
Offer a very short reply. 1.23. What is the ratio of the ODA received (in %) of Liberia in 2007 to that in 2009?
Your answer should be very brief. 2.14. What is the ratio of the ODA received (in %) in Serbia in 2007 to that in 2009?
Your response must be concise. 0.95. What is the ratio of the ODA received (in %) of Bosnia and Herzegovina in 2007 to that in 2010?
Ensure brevity in your answer.  0.8. What is the ratio of the ODA received (in %) of Liberia in 2007 to that in 2010?
Your answer should be very brief. 0.87. What is the ratio of the ODA received (in %) of Serbia in 2007 to that in 2010?
Provide a short and direct response. 0.79. What is the ratio of the ODA received (in %) in Bosnia and Herzegovina in 2008 to that in 2009?
Your response must be concise. 0.75. What is the ratio of the ODA received (in %) of Liberia in 2008 to that in 2009?
Give a very brief answer. 3.32. What is the ratio of the ODA received (in %) of Panama in 2008 to that in 2009?
Offer a very short reply. 0.43. What is the ratio of the ODA received (in %) in Serbia in 2008 to that in 2009?
Ensure brevity in your answer.  0.86. What is the ratio of the ODA received (in %) of Bosnia and Herzegovina in 2008 to that in 2010?
Your answer should be very brief. 0.49. What is the ratio of the ODA received (in %) in Liberia in 2008 to that in 2010?
Keep it short and to the point. 1.34. What is the ratio of the ODA received (in %) of Panama in 2008 to that in 2010?
Offer a terse response. 0.24. What is the ratio of the ODA received (in %) of Serbia in 2008 to that in 2010?
Make the answer very short. 0.72. What is the ratio of the ODA received (in %) of Bosnia and Herzegovina in 2009 to that in 2010?
Provide a short and direct response. 0.65. What is the ratio of the ODA received (in %) of Liberia in 2009 to that in 2010?
Ensure brevity in your answer.  0.4. What is the ratio of the ODA received (in %) in Panama in 2009 to that in 2010?
Keep it short and to the point. 0.56. What is the ratio of the ODA received (in %) of Serbia in 2009 to that in 2010?
Ensure brevity in your answer.  0.83. What is the difference between the highest and the second highest ODA received (in %) in Bosnia and Herzegovina?
Give a very brief answer. 16.07. What is the difference between the highest and the second highest ODA received (in %) in Liberia?
Provide a short and direct response. 193.02. What is the difference between the highest and the second highest ODA received (in %) in Panama?
Offer a terse response. 0.81. What is the difference between the highest and the second highest ODA received (in %) of Serbia?
Your response must be concise. 4.19. What is the difference between the highest and the lowest ODA received (in %) in Bosnia and Herzegovina?
Make the answer very short. 26.12. What is the difference between the highest and the lowest ODA received (in %) of Liberia?
Provide a short and direct response. 548.54. What is the difference between the highest and the lowest ODA received (in %) in Panama?
Give a very brief answer. 1.87. What is the difference between the highest and the lowest ODA received (in %) in Serbia?
Ensure brevity in your answer.  14.08. 